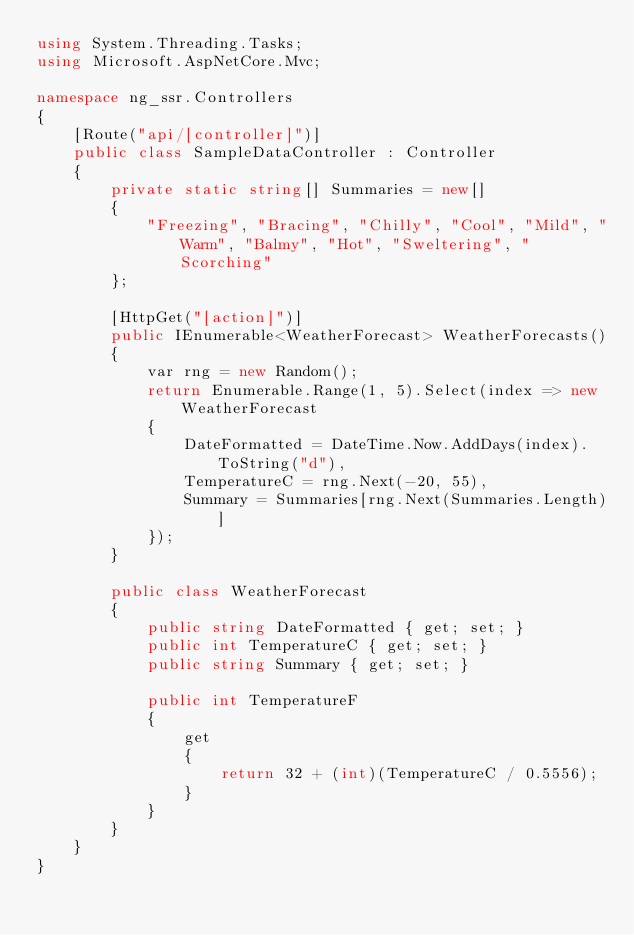Convert code to text. <code><loc_0><loc_0><loc_500><loc_500><_C#_>using System.Threading.Tasks;
using Microsoft.AspNetCore.Mvc;

namespace ng_ssr.Controllers
{
    [Route("api/[controller]")]
    public class SampleDataController : Controller
    {
        private static string[] Summaries = new[]
        {
            "Freezing", "Bracing", "Chilly", "Cool", "Mild", "Warm", "Balmy", "Hot", "Sweltering", "Scorching"
        };

        [HttpGet("[action]")]
        public IEnumerable<WeatherForecast> WeatherForecasts()
        {
            var rng = new Random();
            return Enumerable.Range(1, 5).Select(index => new WeatherForecast
            {
                DateFormatted = DateTime.Now.AddDays(index).ToString("d"),
                TemperatureC = rng.Next(-20, 55),
                Summary = Summaries[rng.Next(Summaries.Length)]
            });
        }

        public class WeatherForecast
        {
            public string DateFormatted { get; set; }
            public int TemperatureC { get; set; }
            public string Summary { get; set; }

            public int TemperatureF
            {
                get
                {
                    return 32 + (int)(TemperatureC / 0.5556);
                }
            }
        }
    }
}
</code> 